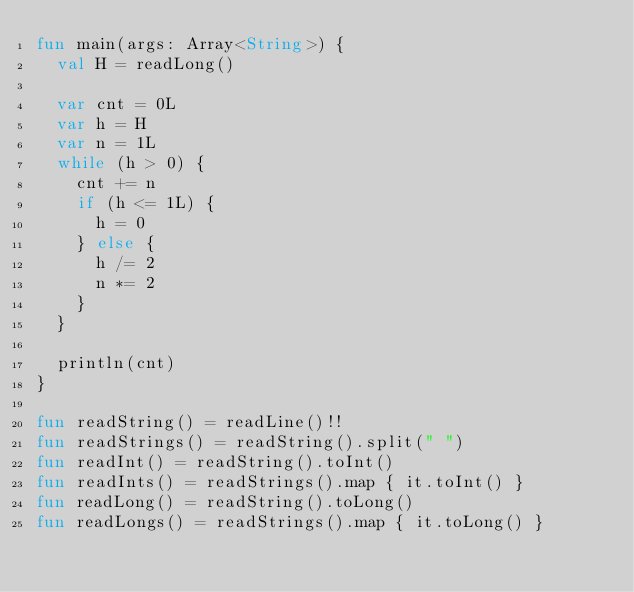<code> <loc_0><loc_0><loc_500><loc_500><_Kotlin_>fun main(args: Array<String>) {
  val H = readLong()

  var cnt = 0L
  var h = H
  var n = 1L
  while (h > 0) {
    cnt += n
    if (h <= 1L) {
      h = 0
    } else {
      h /= 2
      n *= 2
    }
  }

  println(cnt)
}

fun readString() = readLine()!!
fun readStrings() = readString().split(" ")
fun readInt() = readString().toInt()
fun readInts() = readStrings().map { it.toInt() }
fun readLong() = readString().toLong()
fun readLongs() = readStrings().map { it.toLong() }
</code> 